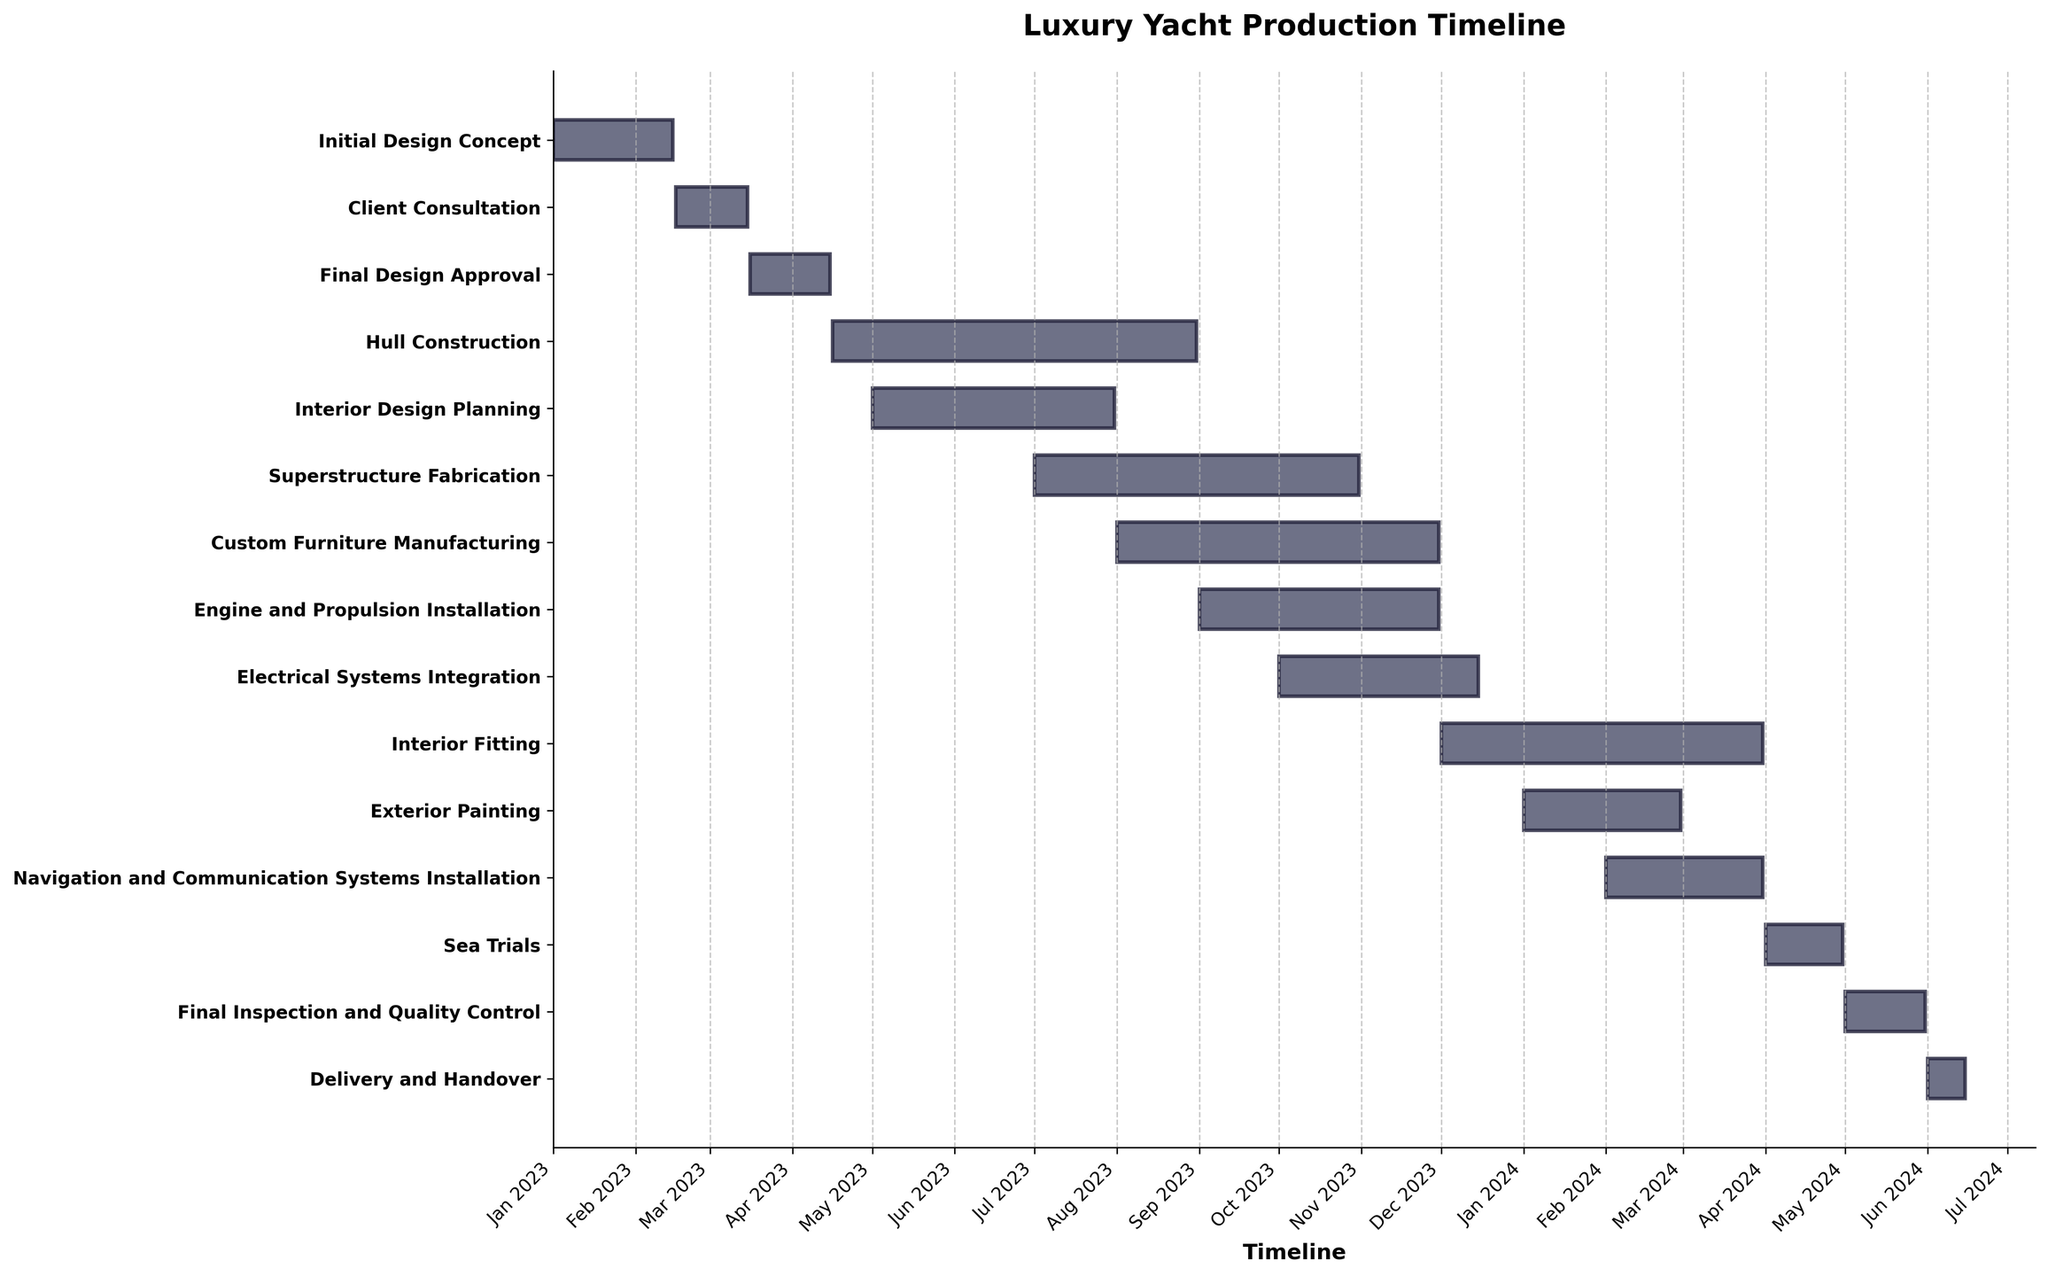what is the title of the figure? The title is located at the top of the figure. It provides a succinct summary of what the figure represents. In this case, the title reads "Luxury Yacht Production Timeline" which clearly defines the subject of the figure.
Answer: Luxury Yacht Production Timeline How many tasks are included in the production timeline? To find the number of tasks, look at the y-axis of the Gantt chart which lists all the tasks. Each task is shown as a separate horizontal bar. Count the number of these bars to get the total number of tasks. There are 14 tasks listed in the production timeline.
Answer: 14 When does the 'Hull Construction' stage start and end? Look at the horizontal bar labeled 'Hull Construction'. The start and end dates are marked at the beginning and end of the bar. For 'Hull Construction,' the bar starts on 'Apr 2023' and ends on 'Aug 2023'. So the stage starts on April 16, 2023, and ends on August 31, 2023.
Answer: April 16, 2023 to August 31, 2023 Which stage overlaps the most with 'Superstructure Fabrication'? Identify the 'Superstructure Fabrication' bar and look for other bars that overlap with it. 'Hull Construction' overlaps with 'Superstructure Fabrication' from July 1 to August 31, and 'Interior Design Planning' overlaps from July 1 to July 31. By examining the overlapping durations, it is evident 'Hull Construction' overlaps the most.
Answer: Hull Construction What is the total duration for 'Custom Furniture Manufacturing'? Find the 'Custom Furniture Manufacturing' bar and note the start and end dates. It starts from 'Aug 1, 2023', and ends on 'Nov 30, 2023'. Calculate the number of days between these dates. Duration: 122 days, considering that it spans four full months.
Answer: 122 days How many tasks are scheduled to be completed by the end of 2023? Identify tasks whose end date is in 2023. These are: 'Initial Design Concept', 'Client Consultation', 'Final Design Approval', 'Hull Construction', 'Superstructure Fabrication', 'Interior Design Planning', 'Engine and Propulsion Installation', 'Electrical Systems Integration', and 'Custom Furniture Manufacturing'. Count each of these tasks. There are 9 tasks finishing by the end of 2023.
Answer: 9 When does 'Interior Fitting' take place? Look at the 'Interior Fitting' bar on the Gantt chart. Note the start and end dates. 'Interior Fitting' starts on December 1, 2023, and ends on March 31, 2024.
Answer: December 1, 2023 to March 31, 2024 Which stage is the last one to be completed before 'Delivery and Handover'? Locate the 'Delivery and Handover' bar and see which task comes just before it on the timeline. The task immediately preceding 'Delivery and Handover' is 'Final Inspection and Quality Control', which finishes on May 31, 2024.
Answer: Final Inspection and Quality Control How many stages are ongoing in January 2024? Identify the stages active in January 2024 by checking which bars span this month. The tasks that continue into January are: 'Electrical Systems Integration', 'Custom Furniture Manufacturing', 'Interior Fitting', and 'Exterior Painting'. Count these tasks. There are 4 tasks ongoing in January 2024.
Answer: 4 